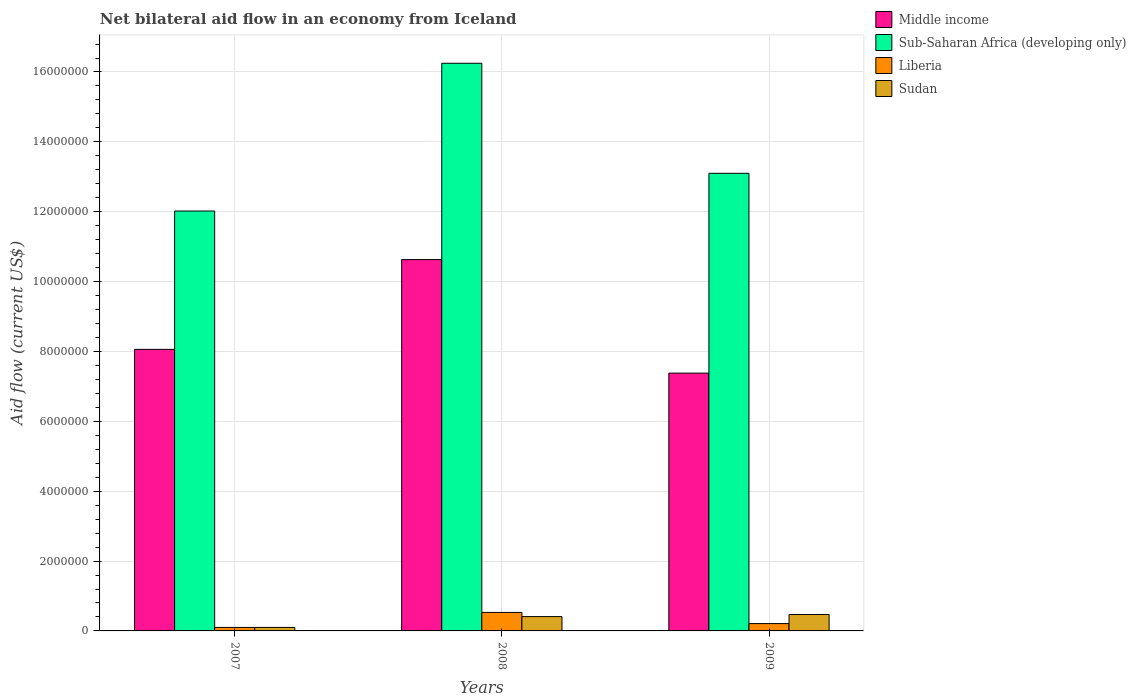Are the number of bars per tick equal to the number of legend labels?
Your answer should be very brief. Yes. Are the number of bars on each tick of the X-axis equal?
Provide a short and direct response. Yes. What is the label of the 2nd group of bars from the left?
Make the answer very short. 2008. Across all years, what is the maximum net bilateral aid flow in Middle income?
Provide a short and direct response. 1.06e+07. Across all years, what is the minimum net bilateral aid flow in Middle income?
Your response must be concise. 7.38e+06. What is the total net bilateral aid flow in Middle income in the graph?
Keep it short and to the point. 2.61e+07. What is the difference between the net bilateral aid flow in Sudan in 2007 and that in 2009?
Make the answer very short. -3.70e+05. What is the difference between the net bilateral aid flow in Sudan in 2008 and the net bilateral aid flow in Middle income in 2009?
Offer a terse response. -6.97e+06. What is the average net bilateral aid flow in Liberia per year?
Offer a terse response. 2.80e+05. In the year 2007, what is the difference between the net bilateral aid flow in Middle income and net bilateral aid flow in Sudan?
Ensure brevity in your answer.  7.96e+06. What is the ratio of the net bilateral aid flow in Liberia in 2007 to that in 2009?
Offer a terse response. 0.48. Is the net bilateral aid flow in Middle income in 2007 less than that in 2009?
Your answer should be compact. No. In how many years, is the net bilateral aid flow in Middle income greater than the average net bilateral aid flow in Middle income taken over all years?
Provide a short and direct response. 1. What does the 1st bar from the left in 2009 represents?
Your answer should be very brief. Middle income. What does the 2nd bar from the right in 2009 represents?
Make the answer very short. Liberia. Are all the bars in the graph horizontal?
Give a very brief answer. No. What is the difference between two consecutive major ticks on the Y-axis?
Your response must be concise. 2.00e+06. Does the graph contain grids?
Make the answer very short. Yes. How many legend labels are there?
Offer a very short reply. 4. How are the legend labels stacked?
Offer a terse response. Vertical. What is the title of the graph?
Offer a terse response. Net bilateral aid flow in an economy from Iceland. What is the label or title of the X-axis?
Your answer should be compact. Years. What is the Aid flow (current US$) of Middle income in 2007?
Offer a terse response. 8.06e+06. What is the Aid flow (current US$) of Sub-Saharan Africa (developing only) in 2007?
Offer a very short reply. 1.20e+07. What is the Aid flow (current US$) in Middle income in 2008?
Provide a succinct answer. 1.06e+07. What is the Aid flow (current US$) in Sub-Saharan Africa (developing only) in 2008?
Provide a succinct answer. 1.62e+07. What is the Aid flow (current US$) in Liberia in 2008?
Your response must be concise. 5.30e+05. What is the Aid flow (current US$) of Sudan in 2008?
Offer a very short reply. 4.10e+05. What is the Aid flow (current US$) of Middle income in 2009?
Provide a short and direct response. 7.38e+06. What is the Aid flow (current US$) of Sub-Saharan Africa (developing only) in 2009?
Offer a terse response. 1.31e+07. What is the Aid flow (current US$) of Liberia in 2009?
Give a very brief answer. 2.10e+05. What is the Aid flow (current US$) in Sudan in 2009?
Offer a terse response. 4.70e+05. Across all years, what is the maximum Aid flow (current US$) of Middle income?
Offer a terse response. 1.06e+07. Across all years, what is the maximum Aid flow (current US$) in Sub-Saharan Africa (developing only)?
Your answer should be compact. 1.62e+07. Across all years, what is the maximum Aid flow (current US$) of Liberia?
Your response must be concise. 5.30e+05. Across all years, what is the minimum Aid flow (current US$) in Middle income?
Give a very brief answer. 7.38e+06. Across all years, what is the minimum Aid flow (current US$) of Sub-Saharan Africa (developing only)?
Provide a short and direct response. 1.20e+07. Across all years, what is the minimum Aid flow (current US$) of Sudan?
Offer a terse response. 1.00e+05. What is the total Aid flow (current US$) in Middle income in the graph?
Give a very brief answer. 2.61e+07. What is the total Aid flow (current US$) of Sub-Saharan Africa (developing only) in the graph?
Keep it short and to the point. 4.14e+07. What is the total Aid flow (current US$) of Liberia in the graph?
Provide a short and direct response. 8.40e+05. What is the total Aid flow (current US$) of Sudan in the graph?
Provide a succinct answer. 9.80e+05. What is the difference between the Aid flow (current US$) in Middle income in 2007 and that in 2008?
Give a very brief answer. -2.57e+06. What is the difference between the Aid flow (current US$) in Sub-Saharan Africa (developing only) in 2007 and that in 2008?
Provide a short and direct response. -4.23e+06. What is the difference between the Aid flow (current US$) in Liberia in 2007 and that in 2008?
Your response must be concise. -4.30e+05. What is the difference between the Aid flow (current US$) of Sudan in 2007 and that in 2008?
Your answer should be compact. -3.10e+05. What is the difference between the Aid flow (current US$) of Middle income in 2007 and that in 2009?
Provide a short and direct response. 6.80e+05. What is the difference between the Aid flow (current US$) in Sub-Saharan Africa (developing only) in 2007 and that in 2009?
Give a very brief answer. -1.08e+06. What is the difference between the Aid flow (current US$) of Sudan in 2007 and that in 2009?
Provide a succinct answer. -3.70e+05. What is the difference between the Aid flow (current US$) in Middle income in 2008 and that in 2009?
Your answer should be compact. 3.25e+06. What is the difference between the Aid flow (current US$) in Sub-Saharan Africa (developing only) in 2008 and that in 2009?
Ensure brevity in your answer.  3.15e+06. What is the difference between the Aid flow (current US$) of Liberia in 2008 and that in 2009?
Provide a short and direct response. 3.20e+05. What is the difference between the Aid flow (current US$) of Middle income in 2007 and the Aid flow (current US$) of Sub-Saharan Africa (developing only) in 2008?
Keep it short and to the point. -8.19e+06. What is the difference between the Aid flow (current US$) in Middle income in 2007 and the Aid flow (current US$) in Liberia in 2008?
Keep it short and to the point. 7.53e+06. What is the difference between the Aid flow (current US$) in Middle income in 2007 and the Aid flow (current US$) in Sudan in 2008?
Give a very brief answer. 7.65e+06. What is the difference between the Aid flow (current US$) of Sub-Saharan Africa (developing only) in 2007 and the Aid flow (current US$) of Liberia in 2008?
Give a very brief answer. 1.15e+07. What is the difference between the Aid flow (current US$) of Sub-Saharan Africa (developing only) in 2007 and the Aid flow (current US$) of Sudan in 2008?
Offer a terse response. 1.16e+07. What is the difference between the Aid flow (current US$) of Liberia in 2007 and the Aid flow (current US$) of Sudan in 2008?
Offer a terse response. -3.10e+05. What is the difference between the Aid flow (current US$) in Middle income in 2007 and the Aid flow (current US$) in Sub-Saharan Africa (developing only) in 2009?
Provide a succinct answer. -5.04e+06. What is the difference between the Aid flow (current US$) of Middle income in 2007 and the Aid flow (current US$) of Liberia in 2009?
Keep it short and to the point. 7.85e+06. What is the difference between the Aid flow (current US$) of Middle income in 2007 and the Aid flow (current US$) of Sudan in 2009?
Your answer should be very brief. 7.59e+06. What is the difference between the Aid flow (current US$) in Sub-Saharan Africa (developing only) in 2007 and the Aid flow (current US$) in Liberia in 2009?
Your response must be concise. 1.18e+07. What is the difference between the Aid flow (current US$) in Sub-Saharan Africa (developing only) in 2007 and the Aid flow (current US$) in Sudan in 2009?
Provide a succinct answer. 1.16e+07. What is the difference between the Aid flow (current US$) in Liberia in 2007 and the Aid flow (current US$) in Sudan in 2009?
Ensure brevity in your answer.  -3.70e+05. What is the difference between the Aid flow (current US$) in Middle income in 2008 and the Aid flow (current US$) in Sub-Saharan Africa (developing only) in 2009?
Give a very brief answer. -2.47e+06. What is the difference between the Aid flow (current US$) of Middle income in 2008 and the Aid flow (current US$) of Liberia in 2009?
Offer a very short reply. 1.04e+07. What is the difference between the Aid flow (current US$) of Middle income in 2008 and the Aid flow (current US$) of Sudan in 2009?
Ensure brevity in your answer.  1.02e+07. What is the difference between the Aid flow (current US$) in Sub-Saharan Africa (developing only) in 2008 and the Aid flow (current US$) in Liberia in 2009?
Your response must be concise. 1.60e+07. What is the difference between the Aid flow (current US$) in Sub-Saharan Africa (developing only) in 2008 and the Aid flow (current US$) in Sudan in 2009?
Give a very brief answer. 1.58e+07. What is the difference between the Aid flow (current US$) of Liberia in 2008 and the Aid flow (current US$) of Sudan in 2009?
Keep it short and to the point. 6.00e+04. What is the average Aid flow (current US$) in Middle income per year?
Give a very brief answer. 8.69e+06. What is the average Aid flow (current US$) of Sub-Saharan Africa (developing only) per year?
Make the answer very short. 1.38e+07. What is the average Aid flow (current US$) in Liberia per year?
Provide a succinct answer. 2.80e+05. What is the average Aid flow (current US$) in Sudan per year?
Provide a short and direct response. 3.27e+05. In the year 2007, what is the difference between the Aid flow (current US$) of Middle income and Aid flow (current US$) of Sub-Saharan Africa (developing only)?
Your answer should be very brief. -3.96e+06. In the year 2007, what is the difference between the Aid flow (current US$) in Middle income and Aid flow (current US$) in Liberia?
Your response must be concise. 7.96e+06. In the year 2007, what is the difference between the Aid flow (current US$) of Middle income and Aid flow (current US$) of Sudan?
Give a very brief answer. 7.96e+06. In the year 2007, what is the difference between the Aid flow (current US$) in Sub-Saharan Africa (developing only) and Aid flow (current US$) in Liberia?
Ensure brevity in your answer.  1.19e+07. In the year 2007, what is the difference between the Aid flow (current US$) of Sub-Saharan Africa (developing only) and Aid flow (current US$) of Sudan?
Give a very brief answer. 1.19e+07. In the year 2008, what is the difference between the Aid flow (current US$) of Middle income and Aid flow (current US$) of Sub-Saharan Africa (developing only)?
Make the answer very short. -5.62e+06. In the year 2008, what is the difference between the Aid flow (current US$) in Middle income and Aid flow (current US$) in Liberia?
Offer a terse response. 1.01e+07. In the year 2008, what is the difference between the Aid flow (current US$) of Middle income and Aid flow (current US$) of Sudan?
Ensure brevity in your answer.  1.02e+07. In the year 2008, what is the difference between the Aid flow (current US$) in Sub-Saharan Africa (developing only) and Aid flow (current US$) in Liberia?
Your answer should be very brief. 1.57e+07. In the year 2008, what is the difference between the Aid flow (current US$) of Sub-Saharan Africa (developing only) and Aid flow (current US$) of Sudan?
Offer a terse response. 1.58e+07. In the year 2008, what is the difference between the Aid flow (current US$) of Liberia and Aid flow (current US$) of Sudan?
Make the answer very short. 1.20e+05. In the year 2009, what is the difference between the Aid flow (current US$) of Middle income and Aid flow (current US$) of Sub-Saharan Africa (developing only)?
Your answer should be compact. -5.72e+06. In the year 2009, what is the difference between the Aid flow (current US$) in Middle income and Aid flow (current US$) in Liberia?
Your response must be concise. 7.17e+06. In the year 2009, what is the difference between the Aid flow (current US$) in Middle income and Aid flow (current US$) in Sudan?
Ensure brevity in your answer.  6.91e+06. In the year 2009, what is the difference between the Aid flow (current US$) of Sub-Saharan Africa (developing only) and Aid flow (current US$) of Liberia?
Your answer should be compact. 1.29e+07. In the year 2009, what is the difference between the Aid flow (current US$) in Sub-Saharan Africa (developing only) and Aid flow (current US$) in Sudan?
Offer a terse response. 1.26e+07. What is the ratio of the Aid flow (current US$) of Middle income in 2007 to that in 2008?
Offer a terse response. 0.76. What is the ratio of the Aid flow (current US$) of Sub-Saharan Africa (developing only) in 2007 to that in 2008?
Provide a succinct answer. 0.74. What is the ratio of the Aid flow (current US$) in Liberia in 2007 to that in 2008?
Offer a very short reply. 0.19. What is the ratio of the Aid flow (current US$) in Sudan in 2007 to that in 2008?
Offer a very short reply. 0.24. What is the ratio of the Aid flow (current US$) of Middle income in 2007 to that in 2009?
Make the answer very short. 1.09. What is the ratio of the Aid flow (current US$) of Sub-Saharan Africa (developing only) in 2007 to that in 2009?
Provide a succinct answer. 0.92. What is the ratio of the Aid flow (current US$) in Liberia in 2007 to that in 2009?
Make the answer very short. 0.48. What is the ratio of the Aid flow (current US$) of Sudan in 2007 to that in 2009?
Offer a terse response. 0.21. What is the ratio of the Aid flow (current US$) in Middle income in 2008 to that in 2009?
Your answer should be compact. 1.44. What is the ratio of the Aid flow (current US$) of Sub-Saharan Africa (developing only) in 2008 to that in 2009?
Make the answer very short. 1.24. What is the ratio of the Aid flow (current US$) in Liberia in 2008 to that in 2009?
Offer a terse response. 2.52. What is the ratio of the Aid flow (current US$) in Sudan in 2008 to that in 2009?
Give a very brief answer. 0.87. What is the difference between the highest and the second highest Aid flow (current US$) in Middle income?
Your response must be concise. 2.57e+06. What is the difference between the highest and the second highest Aid flow (current US$) of Sub-Saharan Africa (developing only)?
Ensure brevity in your answer.  3.15e+06. What is the difference between the highest and the second highest Aid flow (current US$) of Liberia?
Your answer should be compact. 3.20e+05. What is the difference between the highest and the lowest Aid flow (current US$) in Middle income?
Provide a short and direct response. 3.25e+06. What is the difference between the highest and the lowest Aid flow (current US$) of Sub-Saharan Africa (developing only)?
Give a very brief answer. 4.23e+06. What is the difference between the highest and the lowest Aid flow (current US$) of Sudan?
Make the answer very short. 3.70e+05. 